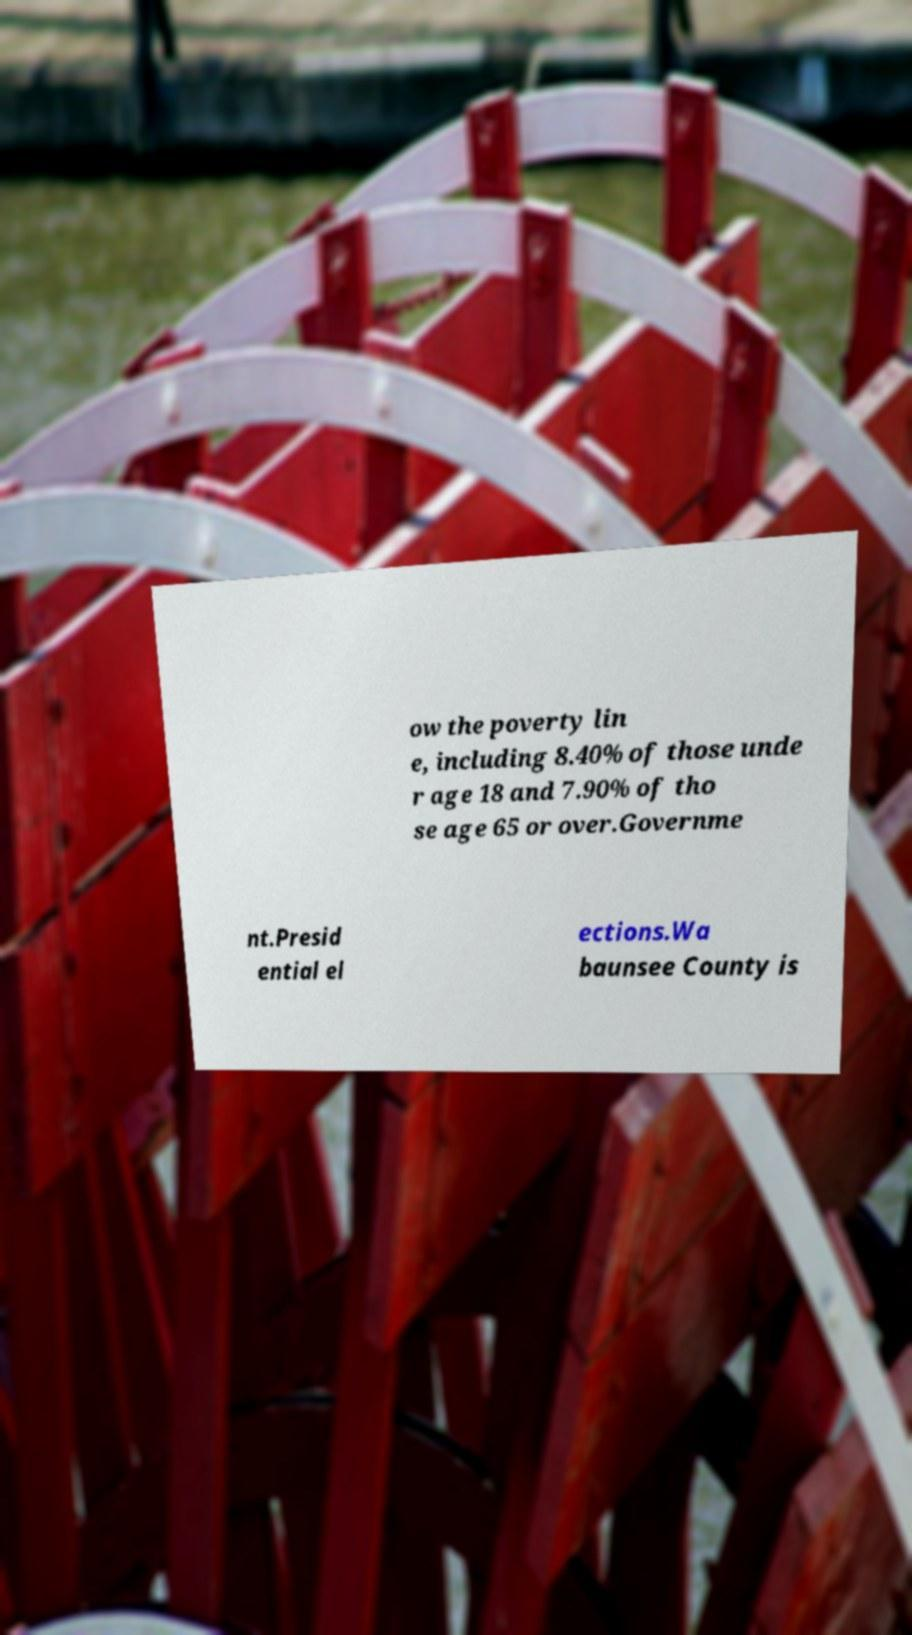Can you read and provide the text displayed in the image?This photo seems to have some interesting text. Can you extract and type it out for me? ow the poverty lin e, including 8.40% of those unde r age 18 and 7.90% of tho se age 65 or over.Governme nt.Presid ential el ections.Wa baunsee County is 